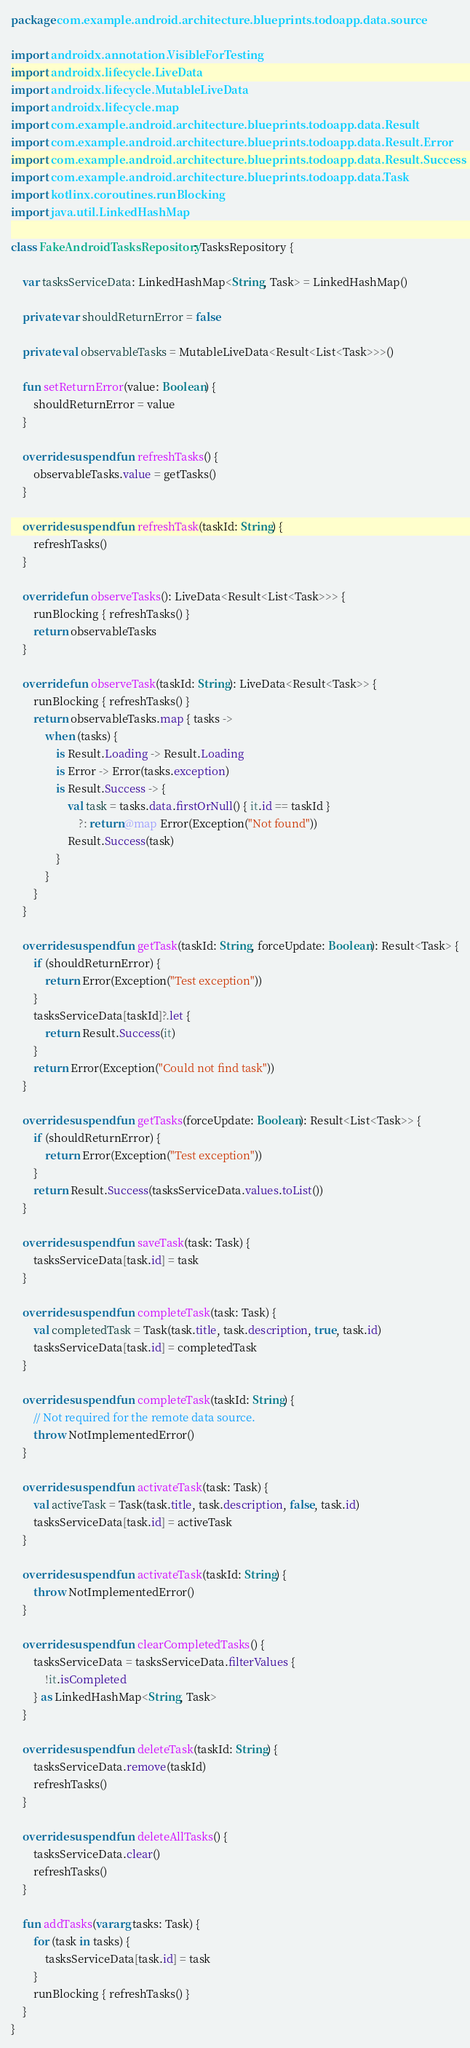<code> <loc_0><loc_0><loc_500><loc_500><_Kotlin_>package com.example.android.architecture.blueprints.todoapp.data.source

import androidx.annotation.VisibleForTesting
import androidx.lifecycle.LiveData
import androidx.lifecycle.MutableLiveData
import androidx.lifecycle.map
import com.example.android.architecture.blueprints.todoapp.data.Result
import com.example.android.architecture.blueprints.todoapp.data.Result.Error
import com.example.android.architecture.blueprints.todoapp.data.Result.Success
import com.example.android.architecture.blueprints.todoapp.data.Task
import kotlinx.coroutines.runBlocking
import java.util.LinkedHashMap

class FakeAndroidTasksRepository: TasksRepository {

    var tasksServiceData: LinkedHashMap<String, Task> = LinkedHashMap()

    private var shouldReturnError = false

    private val observableTasks = MutableLiveData<Result<List<Task>>>()

    fun setReturnError(value: Boolean) {
        shouldReturnError = value
    }

    override suspend fun refreshTasks() {
        observableTasks.value = getTasks()
    }

    override suspend fun refreshTask(taskId: String) {
        refreshTasks()
    }

    override fun observeTasks(): LiveData<Result<List<Task>>> {
        runBlocking { refreshTasks() }
        return observableTasks
    }

    override fun observeTask(taskId: String): LiveData<Result<Task>> {
        runBlocking { refreshTasks() }
        return observableTasks.map { tasks ->
            when (tasks) {
                is Result.Loading -> Result.Loading
                is Error -> Error(tasks.exception)
                is Result.Success -> {
                    val task = tasks.data.firstOrNull() { it.id == taskId }
                        ?: return@map Error(Exception("Not found"))
                    Result.Success(task)
                }
            }
        }
    }

    override suspend fun getTask(taskId: String, forceUpdate: Boolean): Result<Task> {
        if (shouldReturnError) {
            return Error(Exception("Test exception"))
        }
        tasksServiceData[taskId]?.let {
            return Result.Success(it)
        }
        return Error(Exception("Could not find task"))
    }

    override suspend fun getTasks(forceUpdate: Boolean): Result<List<Task>> {
        if (shouldReturnError) {
            return Error(Exception("Test exception"))
        }
        return Result.Success(tasksServiceData.values.toList())
    }

    override suspend fun saveTask(task: Task) {
        tasksServiceData[task.id] = task
    }

    override suspend fun completeTask(task: Task) {
        val completedTask = Task(task.title, task.description, true, task.id)
        tasksServiceData[task.id] = completedTask
    }

    override suspend fun completeTask(taskId: String) {
        // Not required for the remote data source.
        throw NotImplementedError()
    }

    override suspend fun activateTask(task: Task) {
        val activeTask = Task(task.title, task.description, false, task.id)
        tasksServiceData[task.id] = activeTask
    }

    override suspend fun activateTask(taskId: String) {
        throw NotImplementedError()
    }

    override suspend fun clearCompletedTasks() {
        tasksServiceData = tasksServiceData.filterValues {
            !it.isCompleted
        } as LinkedHashMap<String, Task>
    }

    override suspend fun deleteTask(taskId: String) {
        tasksServiceData.remove(taskId)
        refreshTasks()
    }

    override suspend fun deleteAllTasks() {
        tasksServiceData.clear()
        refreshTasks()
    }

    fun addTasks(vararg tasks: Task) {
        for (task in tasks) {
            tasksServiceData[task.id] = task
        }
        runBlocking { refreshTasks() }
    }
}</code> 